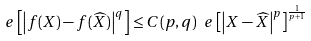Convert formula to latex. <formula><loc_0><loc_0><loc_500><loc_500>\ e \left [ \left | f ( X ) - f ( \widehat { X } ) \right | ^ { q } \right ] \leq C ( p , q ) \ e \left [ \left | X - \widehat { X } \right | ^ { p } \right ] ^ { \frac { 1 } { p + 1 } }</formula> 